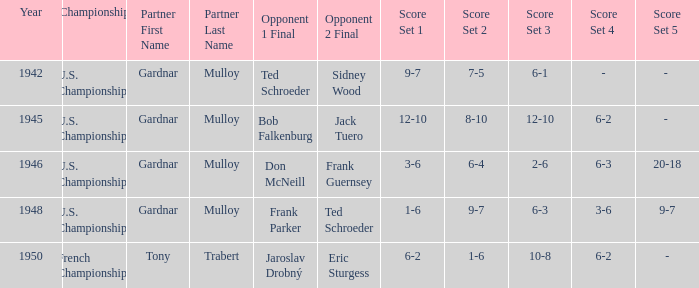What is the most recent year gardnar mulloy played as a partner and score was 12–10, 8–10, 12–10, 6–2? 1945.0. 